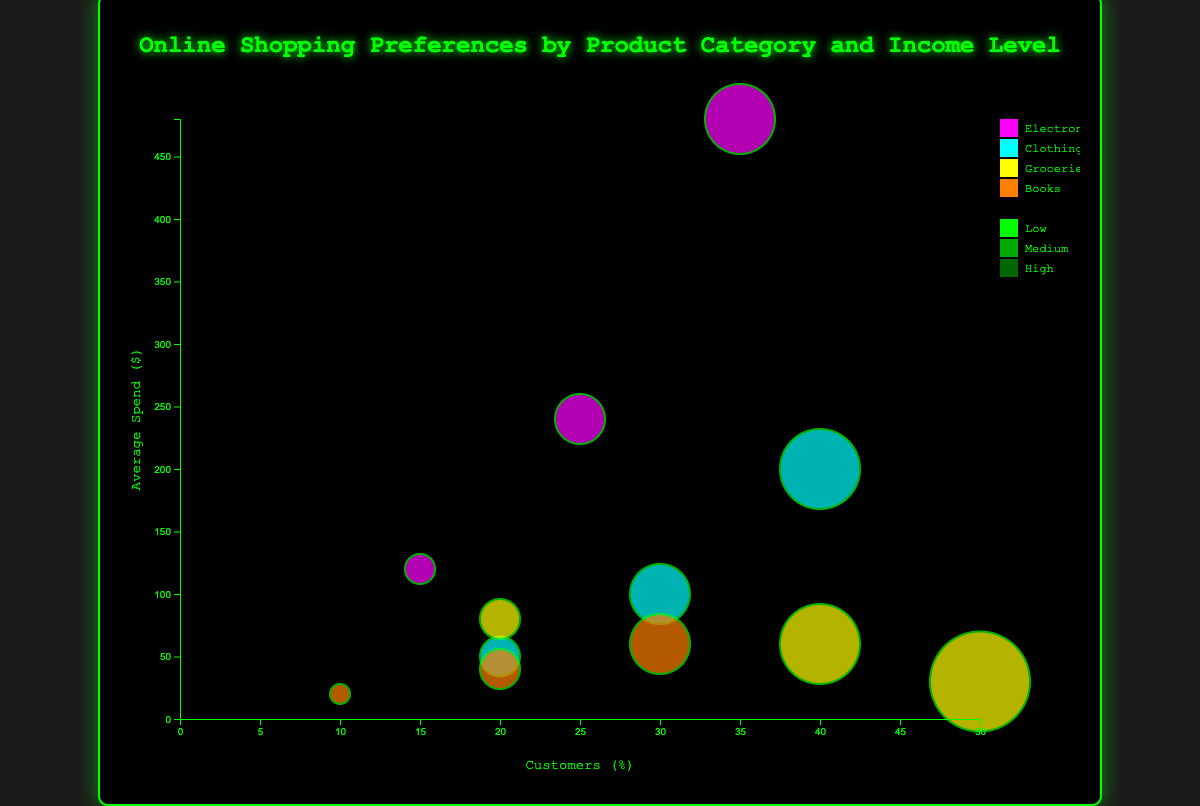What's the title of the chart? The title of the chart is usually found at the top center of the figure. In this case, the title of the chart is "Online Shopping Preferences by Product Category and Income Level."
Answer: "Online Shopping Preferences by Product Category and Income Level" What are the axis labels and what do they represent? The x-axis label is "Customers (%)" and it represents the percentage of customers within each income level that prefer a particular product category. The y-axis label is "Average Spend ($)" and it represents the average monetary expenditure in dollars.
Answer: "Customers (%)" and "Average Spend ($)" Which product category has the bubble with the highest average spend? To find this, we look for the bubble that is positioned highest along the y-axis. The highest point is at the "Electronics" category with a high income level, showing an average spend of $480.
Answer: Electronics Which income group has the largest percentage of customers in the Groceries category? We identify this by looking at the x-axis for the largest percentage within the Groceries category. The "Low" income group, with 50%, has the largest percentage of customers.
Answer: Low Compare the average spend between low and high-income levels for the Electronics category. What can you conclude? From the chart, the low-income level for Electronics has an average spend of $120, while the high-income level for Electronics has an average spend of $480. High-income customers spend significantly more than low-income customers.
Answer: High-income customers spend significantly more How does the number of customers in the "Clothing" category compare across different income levels? By examining the x-axis positions of the bubbles for the "Clothing" category, low-income has 20%, medium-income has 30%, and high-income has 40%. The number of customers increases with the income level.
Answer: Increases with income level Which product category shows the smallest percentage of customers across all income levels combined? To find this, we need to look at the combined percentage across all income levels for each category. Books have 10% (Low) + 20% (Medium) + 30% (High) = 60%, which is the smallest combined percentage.
Answer: Books For the medium-income level, which product category has the highest percentage of customers? Checking the x-axis for the medium-income bubbles, we see that the "Clothing" category has 30%, which is higher than the others.
Answer: Clothing How do the sizes of bubbles correlate with the percentage of customers? The size of the bubbles increases as the percentage of customers increases. This is visually represented by larger bubbles having higher values on the x-axis.
Answer: Larger bubbles have higher customer percentages Among high-income customers, which product category has the lowest average spend? Observing the y-axis values for the high-income category bubbles, "Groceries" has the lowest average spend of $80.
Answer: Groceries 